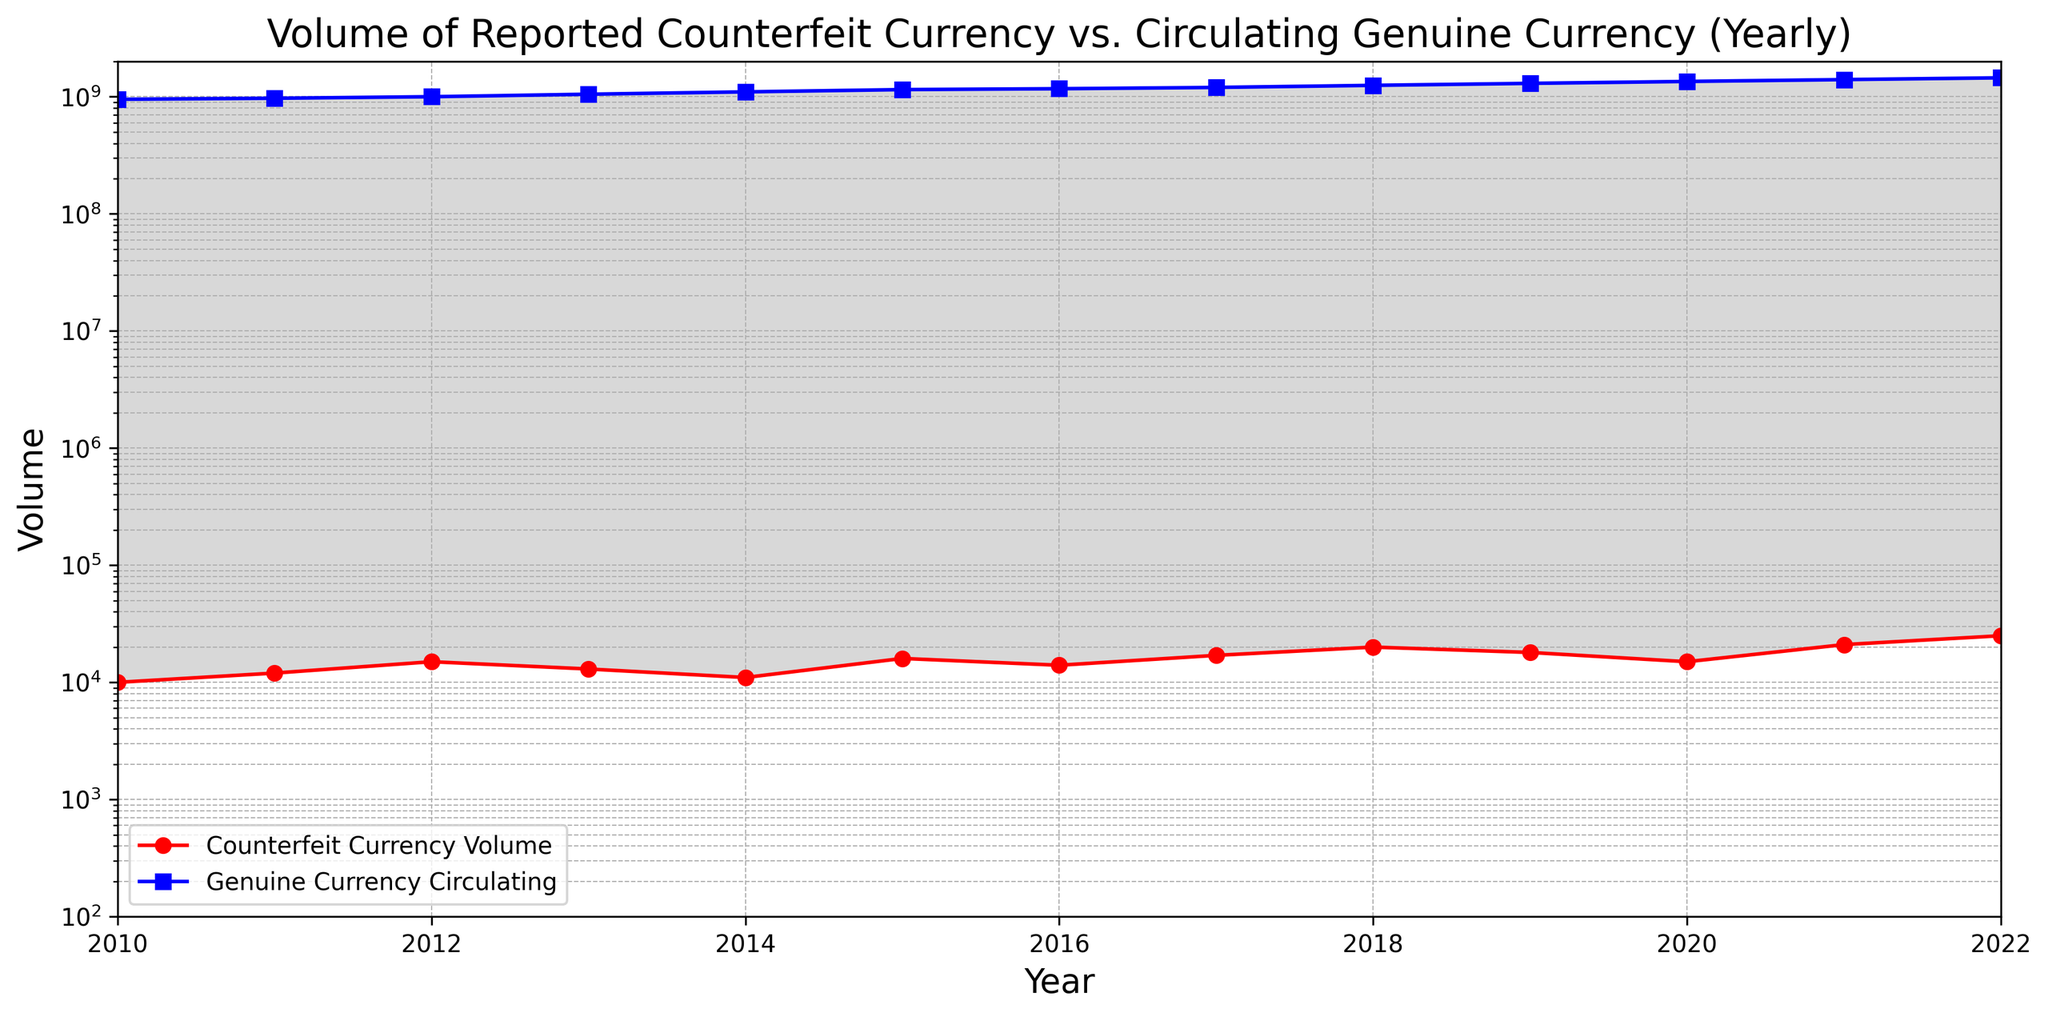What is the general trend of Counterfeit Currency Volume from 2010 to 2022? The line chart shows that the Counterfeit Currency Volume has an overall increasing trend with some fluctuations. It starts at 10,000 in 2010 and rises to 25,000 in 2022 with peaks and dips in between.
Answer: Increasing trend During which year was the volume of Counterfeit Currency the highest? By observing the red line representing Counterfeit Currency Volume, the highest point is in 2022 at 25,000.
Answer: 2022 How does the Genuine Currency Circulating volume compare between 2010 and 2022? In 2010, the volume was 950,000,000, and in 2022, it was 1,450,000,000, indicating an increase over the years.
Answer: Increased Which year shows the largest gap between Counterfeit Currency and Genuine Currency volumes? The gap can be evaluated by the vertical distance between the red and blue lines. The largest visual gap appears to be in 2022.
Answer: 2022 What was the volume of Genuine Currency Circulating in 2015? Referring to the blue line with the marker 's' for the year 2015, the volume was 1,150,000,000.
Answer: 1,150,000,000 Compare the change in Counterfeit Currency Volume from 2018 to 2020. In 2018, the volume was 20,000 and in 2020, it was 15,000. This indicates a decrease of 5,000 over these two years.
Answer: Decreased by 5,000 What is the overall trend of Genuine Currency Circulating from 2010 to 2022? The blue line shows a consistently increasing trend from 2010 (950,000,000) to 2022 (1,450,000,000).
Answer: Increasing trend How many years did the volume of Counterfeit Currency exceed 15,000? Counting the red line data points above 15,000, it occurred in 2015, 2017, 2018, 2021, and 2022 - five years in total.
Answer: 5 years What is the visual difference between the lines representing Counterfeit Currency Volume and Genuine Currency Circulating? The Counterfeit Currency Volume is represented by a red line with circle markers, while Genuine Currency Circulating is a blue line with square markers, and the area between these lines is filled with grey color.
Answer: Red line, blue line, grey fill Compare the Counterfeit Currency Volume in 2012 and 2013. In 2012, the volume was 15,000, while in 2013 it was 13,000, showing a decrease of 2,000.
Answer: Decreased by 2,000 